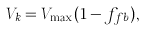<formula> <loc_0><loc_0><loc_500><loc_500>V _ { k } = V _ { \max } ( 1 - f _ { f b } ) ,</formula> 